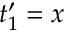Convert formula to latex. <formula><loc_0><loc_0><loc_500><loc_500>t _ { 1 } ^ { \prime } = x</formula> 